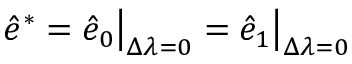<formula> <loc_0><loc_0><loc_500><loc_500>\begin{array} { r } { \hat { e } ^ { * } = \hat { e } _ { 0 } \left | _ { \Delta \lambda = 0 } = \hat { e } _ { 1 } \right | _ { \Delta \lambda = 0 } \, } \end{array}</formula> 